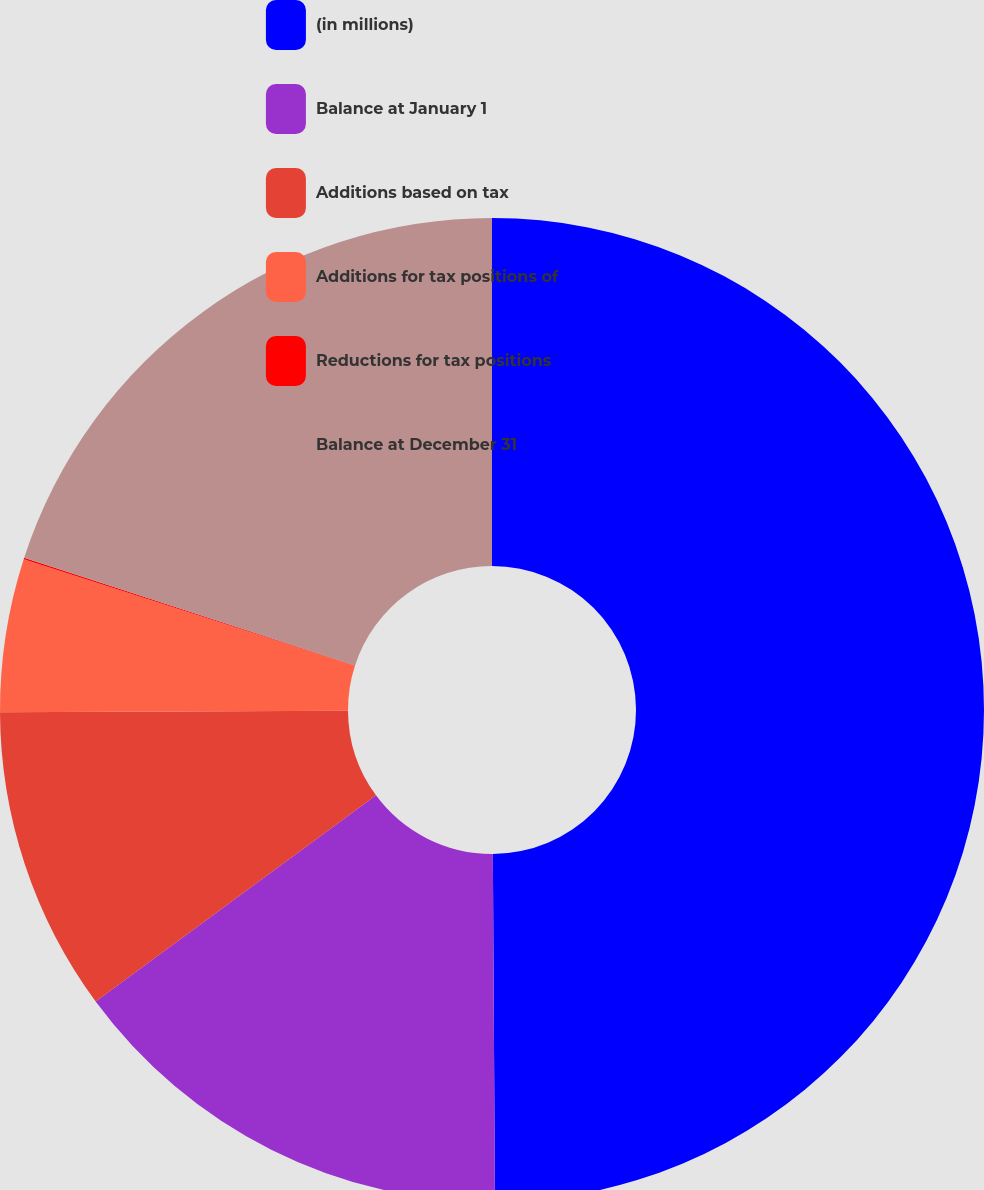<chart> <loc_0><loc_0><loc_500><loc_500><pie_chart><fcel>(in millions)<fcel>Balance at January 1<fcel>Additions based on tax<fcel>Additions for tax positions of<fcel>Reductions for tax positions<fcel>Balance at December 31<nl><fcel>49.9%<fcel>15.0%<fcel>10.02%<fcel>5.03%<fcel>0.05%<fcel>19.99%<nl></chart> 